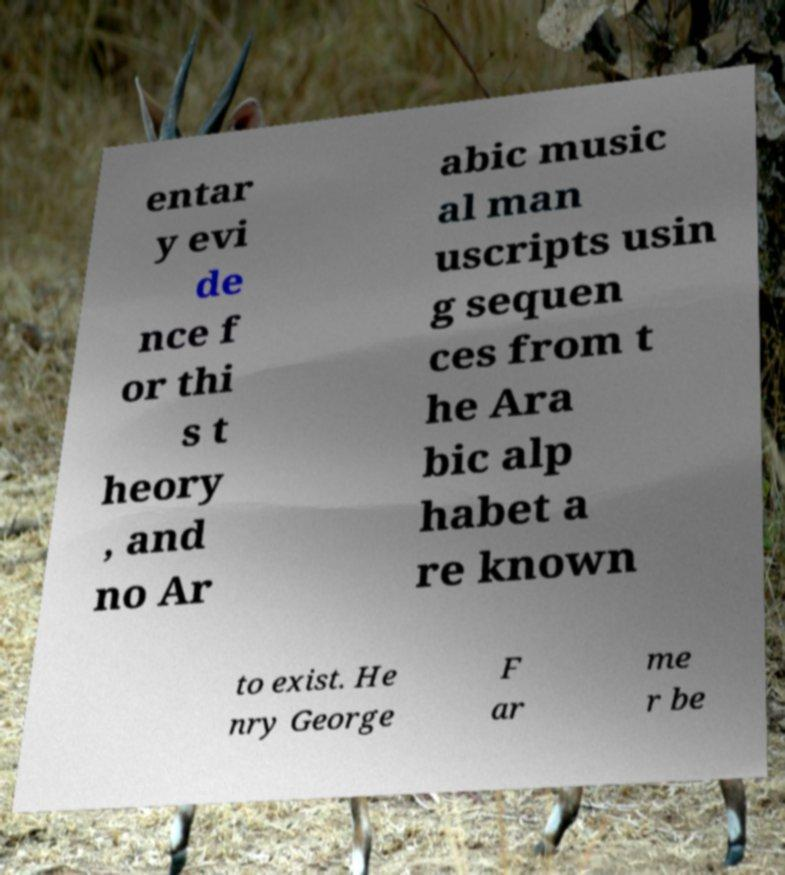Could you assist in decoding the text presented in this image and type it out clearly? entar y evi de nce f or thi s t heory , and no Ar abic music al man uscripts usin g sequen ces from t he Ara bic alp habet a re known to exist. He nry George F ar me r be 